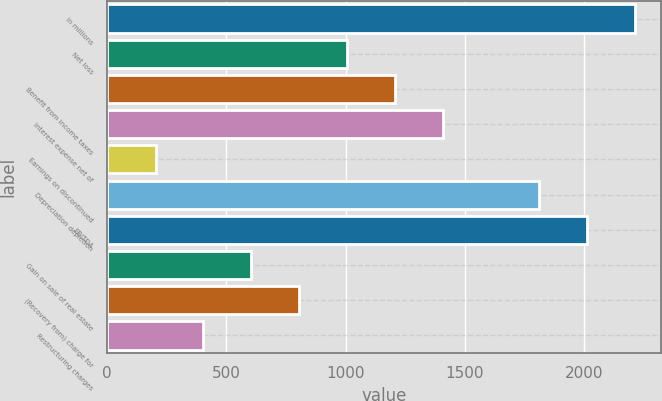Convert chart to OTSL. <chart><loc_0><loc_0><loc_500><loc_500><bar_chart><fcel>in millions<fcel>Net loss<fcel>Benefit from income taxes<fcel>Interest expense net of<fcel>Earnings on discontinued<fcel>Depreciation depletion<fcel>EBITDA<fcel>Gain on sale of real estate<fcel>(Recovery from) charge for<fcel>Restructuring charges<nl><fcel>2211.88<fcel>1006.6<fcel>1207.48<fcel>1408.36<fcel>203.08<fcel>1810.12<fcel>2011<fcel>604.84<fcel>805.72<fcel>403.96<nl></chart> 